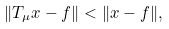<formula> <loc_0><loc_0><loc_500><loc_500>\| T _ { \mu } x - f \| < \| x - f \| ,</formula> 